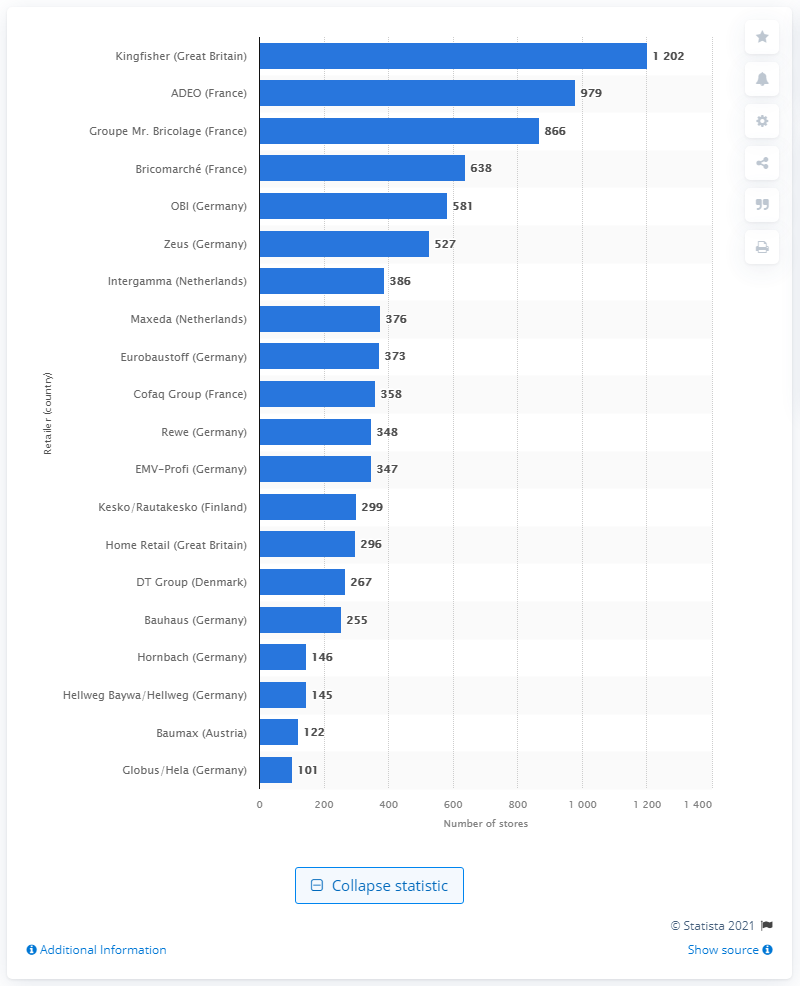List a handful of essential elements in this visual. Kingfisher operated 1202 stores in 2014. 